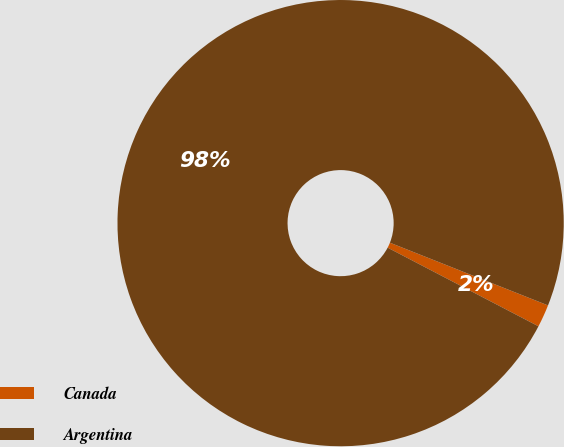<chart> <loc_0><loc_0><loc_500><loc_500><pie_chart><fcel>Canada<fcel>Argentina<nl><fcel>1.64%<fcel>98.36%<nl></chart> 